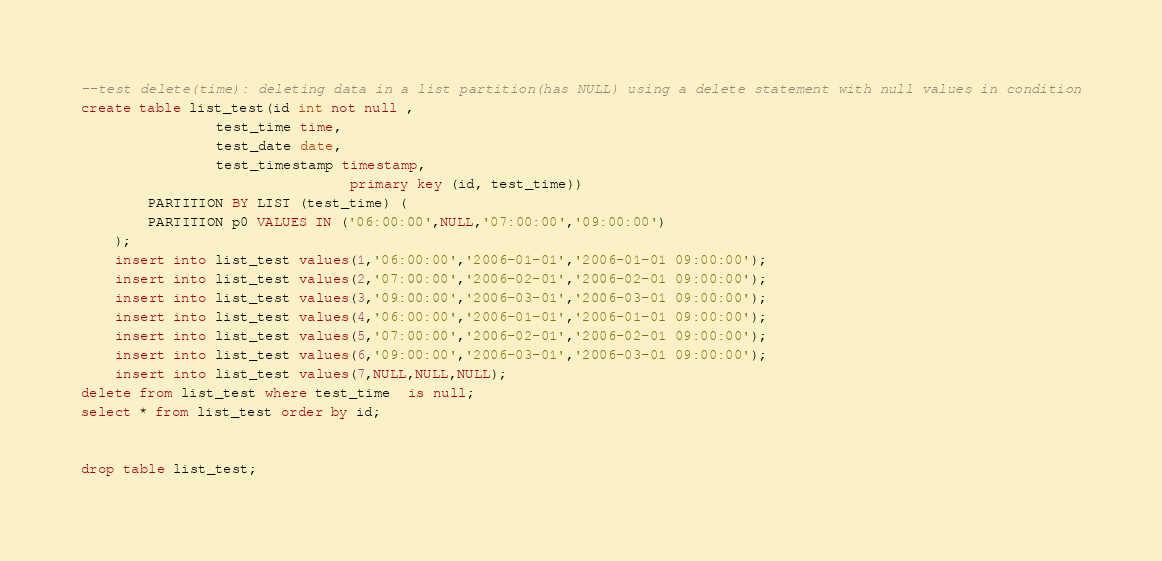Convert code to text. <code><loc_0><loc_0><loc_500><loc_500><_SQL_>--test delete(time): deleting data in a list partition(has NULL) using a delete statement with null values in condition
create table list_test(id int not null ,	
				test_time time,
				test_date date,
				test_timestamp timestamp,
                                primary key (id, test_time))
		PARTITION BY LIST (test_time) (
		PARTITION p0 VALUES IN ('06:00:00',NULL,'07:00:00','09:00:00')
	);
	insert into list_test values(1,'06:00:00','2006-01-01','2006-01-01 09:00:00');
	insert into list_test values(2,'07:00:00','2006-02-01','2006-02-01 09:00:00');
	insert into list_test values(3,'09:00:00','2006-03-01','2006-03-01 09:00:00');
	insert into list_test values(4,'06:00:00','2006-01-01','2006-01-01 09:00:00');
	insert into list_test values(5,'07:00:00','2006-02-01','2006-02-01 09:00:00');
	insert into list_test values(6,'09:00:00','2006-03-01','2006-03-01 09:00:00');
	insert into list_test values(7,NULL,NULL,NULL);
delete from list_test where test_time  is null;
select * from list_test order by id;


drop table list_test;
</code> 